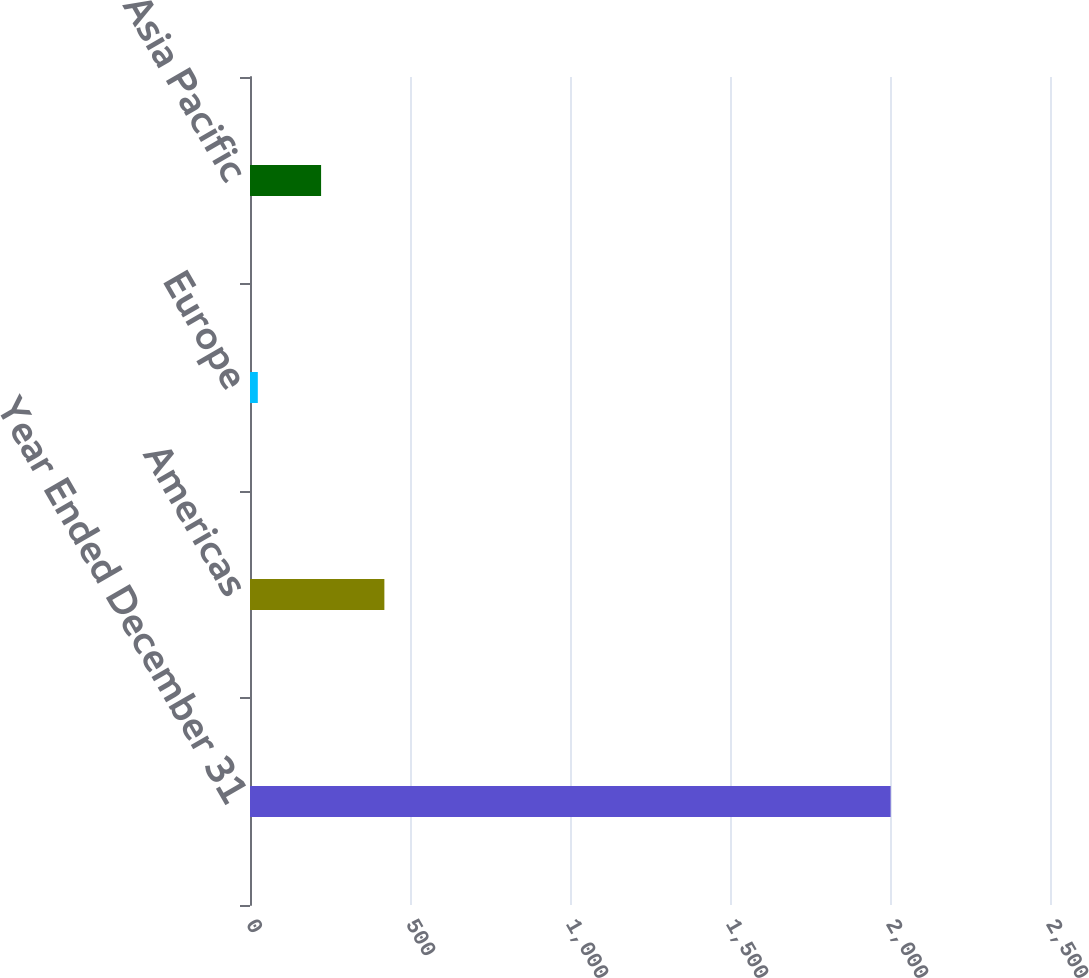Convert chart to OTSL. <chart><loc_0><loc_0><loc_500><loc_500><bar_chart><fcel>Year Ended December 31<fcel>Americas<fcel>Europe<fcel>Asia Pacific<nl><fcel>2002<fcel>419.92<fcel>24.4<fcel>222.16<nl></chart> 